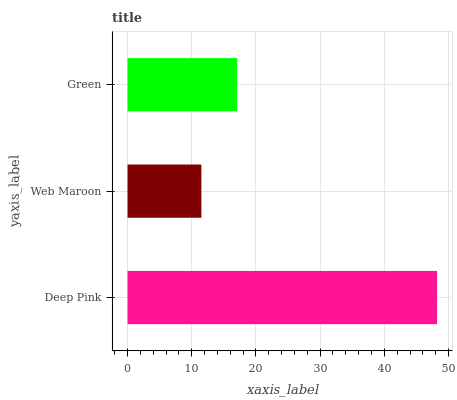Is Web Maroon the minimum?
Answer yes or no. Yes. Is Deep Pink the maximum?
Answer yes or no. Yes. Is Green the minimum?
Answer yes or no. No. Is Green the maximum?
Answer yes or no. No. Is Green greater than Web Maroon?
Answer yes or no. Yes. Is Web Maroon less than Green?
Answer yes or no. Yes. Is Web Maroon greater than Green?
Answer yes or no. No. Is Green less than Web Maroon?
Answer yes or no. No. Is Green the high median?
Answer yes or no. Yes. Is Green the low median?
Answer yes or no. Yes. Is Web Maroon the high median?
Answer yes or no. No. Is Web Maroon the low median?
Answer yes or no. No. 